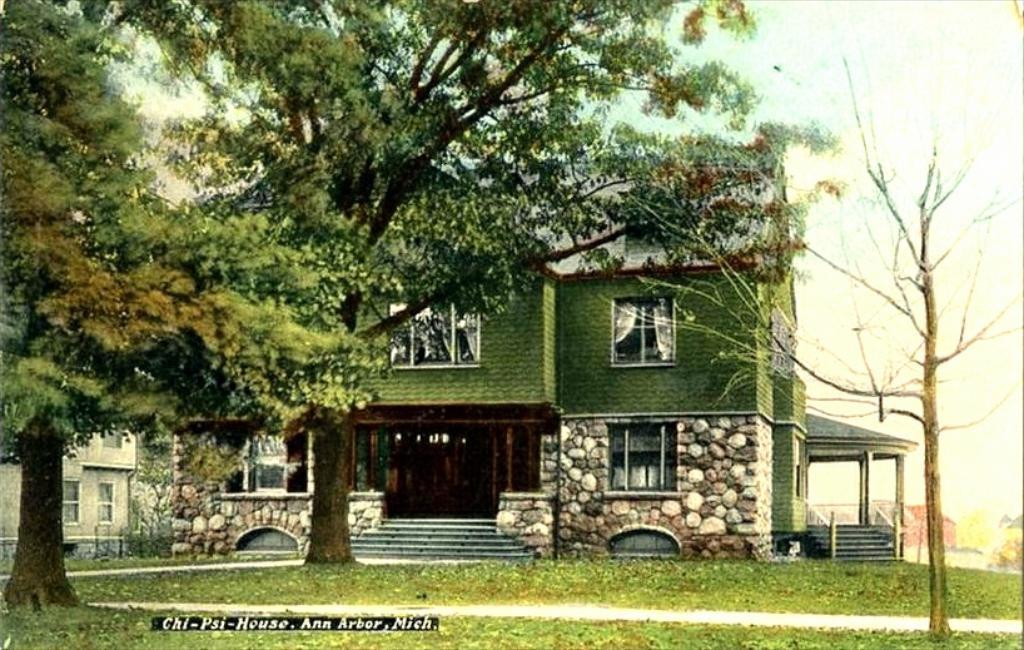How would you summarize this image in a sentence or two? In this picture I can see houses, grass, trees, and in the background there is sky and a watermark on the image. 